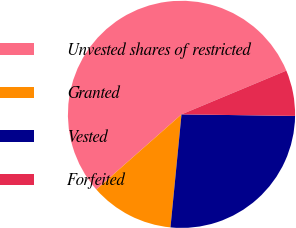Convert chart to OTSL. <chart><loc_0><loc_0><loc_500><loc_500><pie_chart><fcel>Unvested shares of restricted<fcel>Granted<fcel>Vested<fcel>Forfeited<nl><fcel>55.21%<fcel>11.95%<fcel>26.33%<fcel>6.51%<nl></chart> 